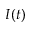Convert formula to latex. <formula><loc_0><loc_0><loc_500><loc_500>I ( t )</formula> 